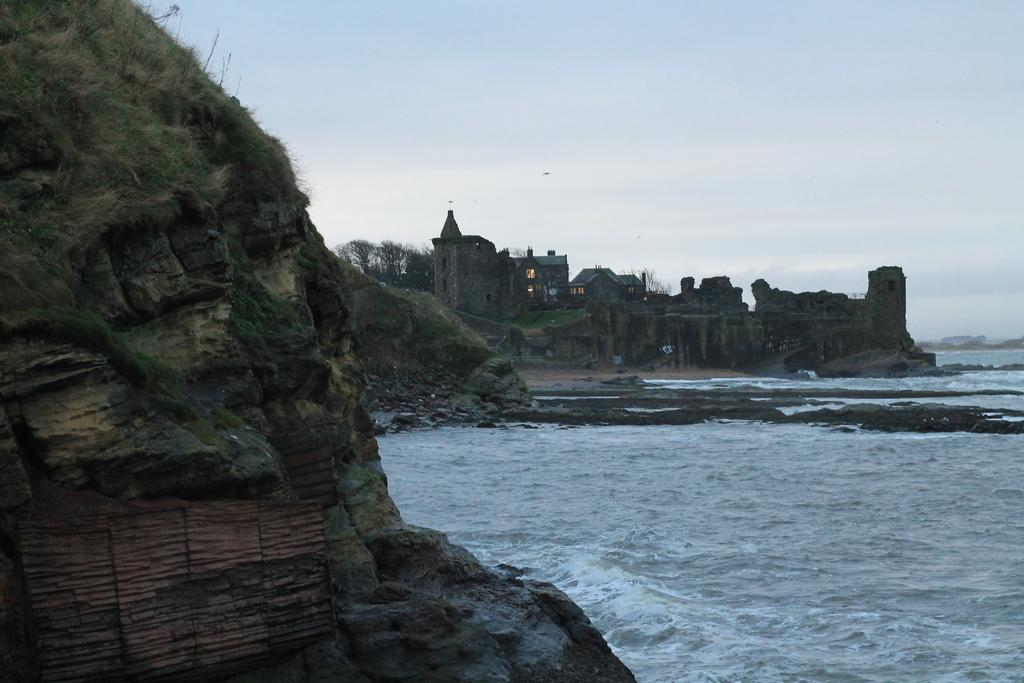What type of structures can be seen in the image? There are buildings in the image. What other natural elements are present in the image? There are trees and water visible in the image. How is the sky depicted on the left side of the image? The sky is cloudy on the left side of the image. What type of cart can be seen in the image? There is no cart present in the image. Is there a rainstorm occurring in the image? No, there is no rainstorm depicted in the image; the sky is simply cloudy on the left side. 